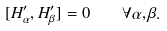<formula> <loc_0><loc_0><loc_500><loc_500>[ H ^ { \prime } _ { \alpha } , H ^ { \prime } _ { \beta } ] = 0 \quad \forall \alpha , \beta .</formula> 